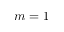<formula> <loc_0><loc_0><loc_500><loc_500>m = 1</formula> 